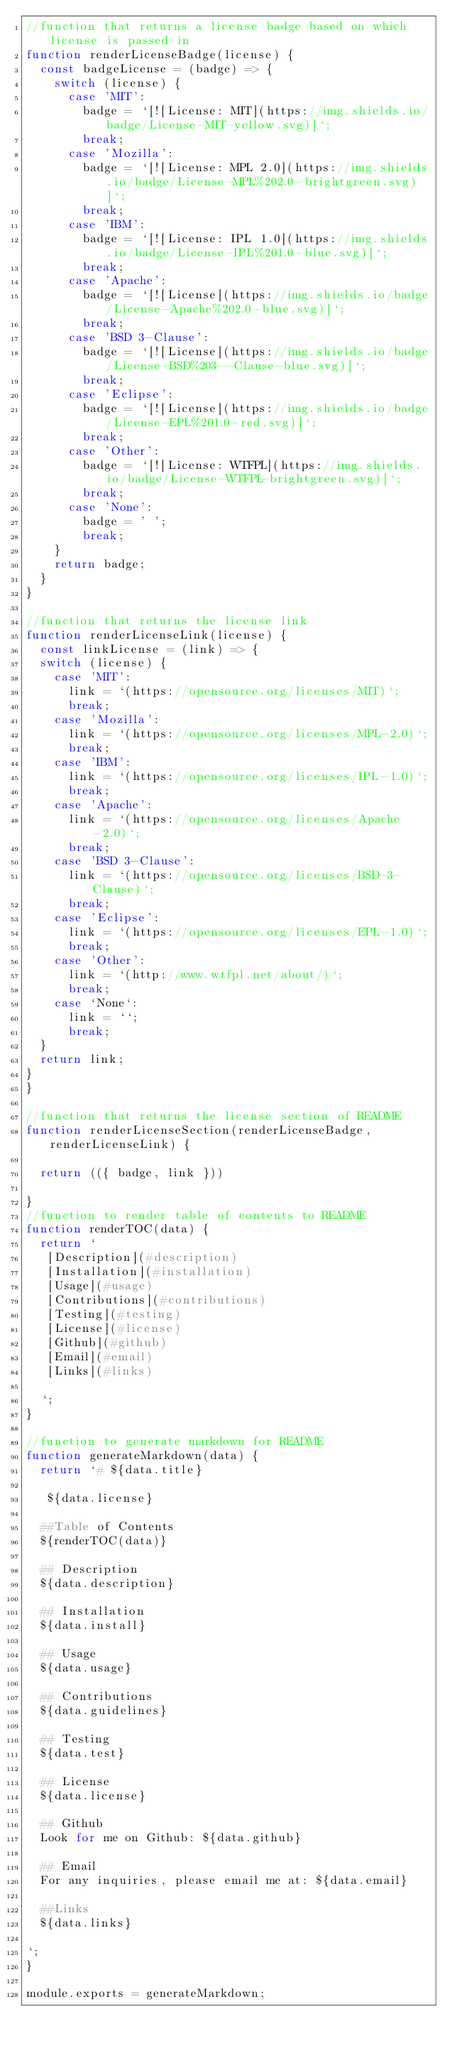<code> <loc_0><loc_0><loc_500><loc_500><_JavaScript_>//function that returns a license badge based on which license is passed in
function renderLicenseBadge(license) {
  const badgeLicense = (badge) => {
    switch (license) {
      case 'MIT':
        badge = `[![License: MIT](https://img.shields.io/badge/License-MIT-yellow.svg)]`;
        break;
      case 'Mozilla':
        badge = `[![License: MPL 2.0](https://img.shields.io/badge/License-MPL%202.0-brightgreen.svg)]`;
        break;
      case 'IBM':
        badge = `[![License: IPL 1.0](https://img.shields.io/badge/License-IPL%201.0-blue.svg)]`;
        break;
      case 'Apache':
        badge = `[![License](https://img.shields.io/badge/License-Apache%202.0-blue.svg)]`;
        break;
      case 'BSD 3-Clause':
        badge = `[![License](https://img.shields.io/badge/License-BSD%203--Clause-blue.svg)]`;
        break;
      case 'Eclipse':
        badge = `[![License](https://img.shields.io/badge/License-EPL%201.0-red.svg)]`;
        break;
      case 'Other':
        badge = `[![License: WTFPL](https://img.shields.io/badge/License-WTFPL-brightgreen.svg)]`;
        break;
      case 'None':
        badge = ' ';
        break;
    }
    return badge;
  }
}

//function that returns the license link
function renderLicenseLink(license) {
  const linkLicense = (link) => {
  switch (license) {
    case 'MIT':
      link = `(https://opensource.org/licenses/MIT)`;
      break;
    case 'Mozilla':
      link = `(https://opensource.org/licenses/MPL-2.0)`;
      break;
    case 'IBM':
      link = `(https://opensource.org/licenses/IPL-1.0)`;
      break;
    case 'Apache':
      link = `(https://opensource.org/licenses/Apache-2.0)`;
      break;
    case 'BSD 3-Clause':
      link = `(https://opensource.org/licenses/BSD-3-Clause)`;
      break;
    case 'Eclipse':
      link = `(https://opensource.org/licenses/EPL-1.0)`;
      break;
    case 'Other':
      link = `(http://www.wtfpl.net/about/)`;
      break;
    case `None`:
      link = ``;
      break;
  }
  return link;
}
}

//function that returns the license section of README
function renderLicenseSection(renderLicenseBadge, renderLicenseLink) {

  return (({ badge, link }))

}
//function to render table of contents to README
function renderTOC(data) {
  return `
   [Description](#description)
   [Installation](#installation)
   [Usage](#usage)
   [Contributions](#contributions)
   [Testing](#testing)
   [License](#license)
   [Github](#github)
   [Email](#email)
   [Links](#links)
  
  `;
}

//function to generate markdown for README
function generateMarkdown(data) {
  return `# ${data.title}
  
   ${data.license}

  ##Table of Contents
  ${renderTOC(data)}

  ## Description
  ${data.description}

  ## Installation
  ${data.install}

  ## Usage
  ${data.usage}

  ## Contributions
  ${data.guidelines}

  ## Testing
  ${data.test}

  ## License
  ${data.license}
    
  ## Github
  Look for me on Github: ${data.github}

  ## Email
  For any inquiries, please email me at: ${data.email}

  ##Links
  ${data.links}

`;
}

module.exports = generateMarkdown;
</code> 